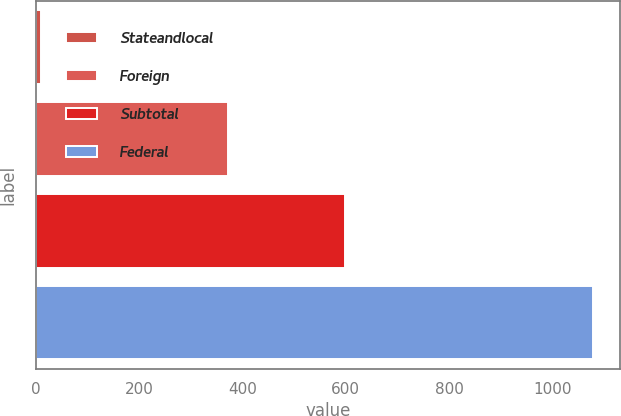Convert chart to OTSL. <chart><loc_0><loc_0><loc_500><loc_500><bar_chart><fcel>Stateandlocal<fcel>Foreign<fcel>Subtotal<fcel>Federal<nl><fcel>10<fcel>372<fcel>598<fcel>1078<nl></chart> 